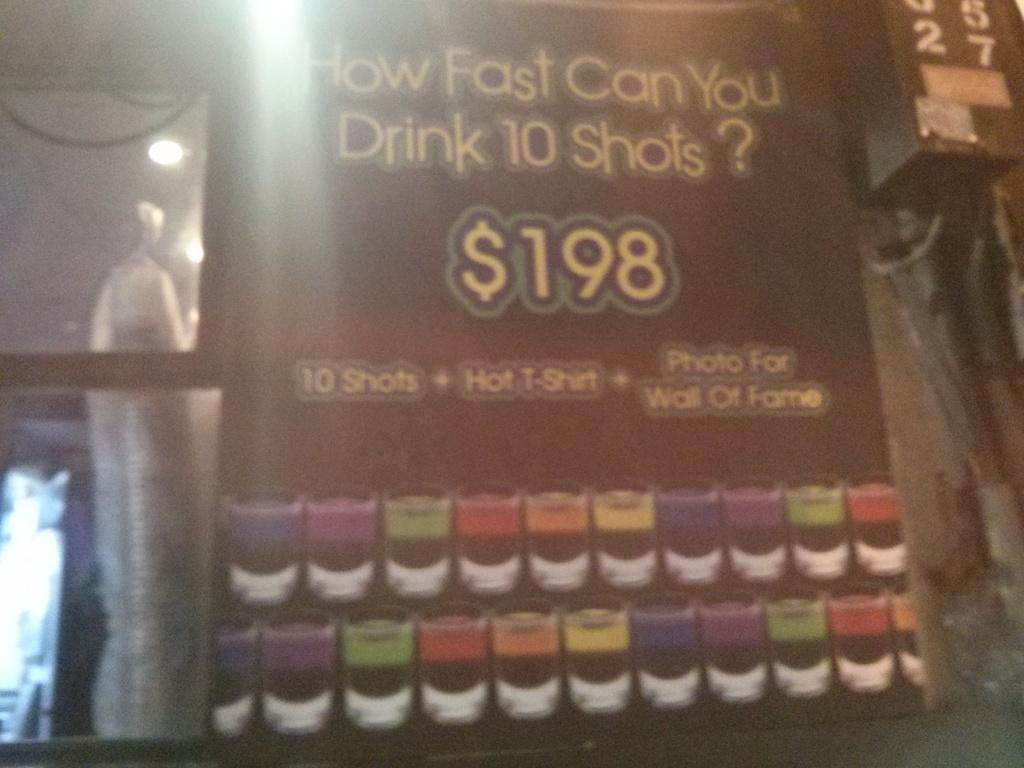<image>
Provide a brief description of the given image. The cost of the challenge shown here is 198 dollars 